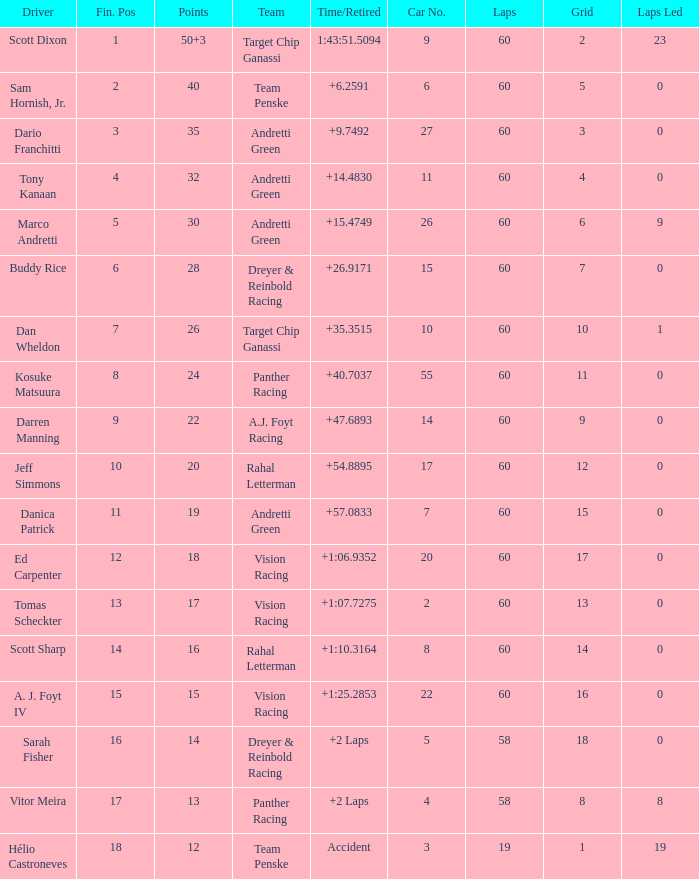Name the laps for 18 pointss 60.0. 